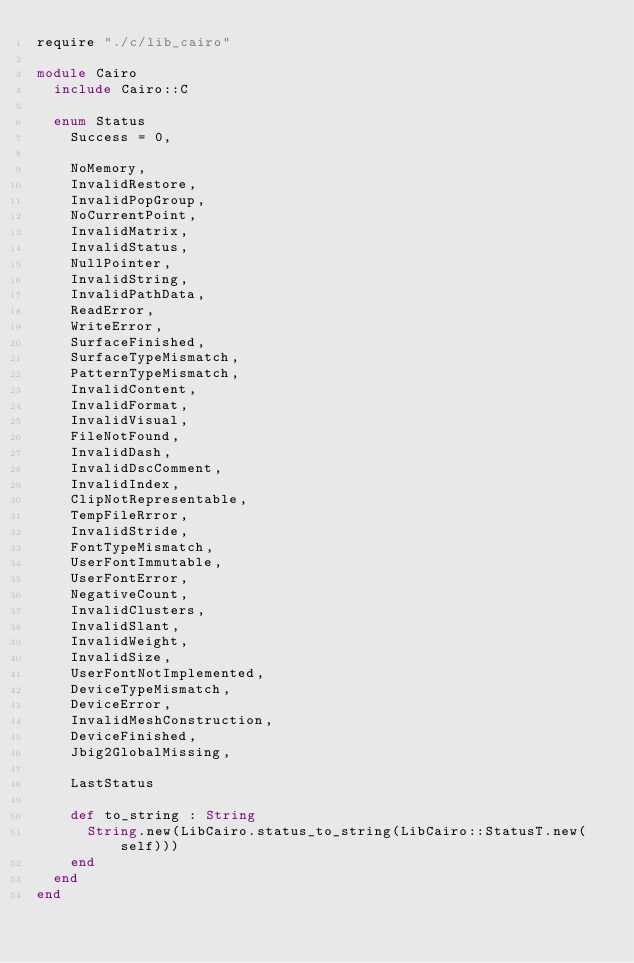<code> <loc_0><loc_0><loc_500><loc_500><_Crystal_>require "./c/lib_cairo"

module Cairo
  include Cairo::C

  enum Status
    Success = 0,

    NoMemory,
    InvalidRestore,
    InvalidPopGroup,
    NoCurrentPoint,
    InvalidMatrix,
    InvalidStatus,
    NullPointer,
    InvalidString,
    InvalidPathData,
    ReadError,
    WriteError,
    SurfaceFinished,
    SurfaceTypeMismatch,
    PatternTypeMismatch,
    InvalidContent,
    InvalidFormat,
    InvalidVisual,
    FileNotFound,
    InvalidDash,
    InvalidDscComment,
    InvalidIndex,
    ClipNotRepresentable,
    TempFileRrror,
    InvalidStride,
    FontTypeMismatch,
    UserFontImmutable,
    UserFontError,
    NegativeCount,
    InvalidClusters,
    InvalidSlant,
    InvalidWeight,
    InvalidSize,
    UserFontNotImplemented,
    DeviceTypeMismatch,
    DeviceError,
    InvalidMeshConstruction,
    DeviceFinished,
    Jbig2GlobalMissing,

    LastStatus

    def to_string : String
      String.new(LibCairo.status_to_string(LibCairo::StatusT.new(self)))
    end
  end
end
</code> 